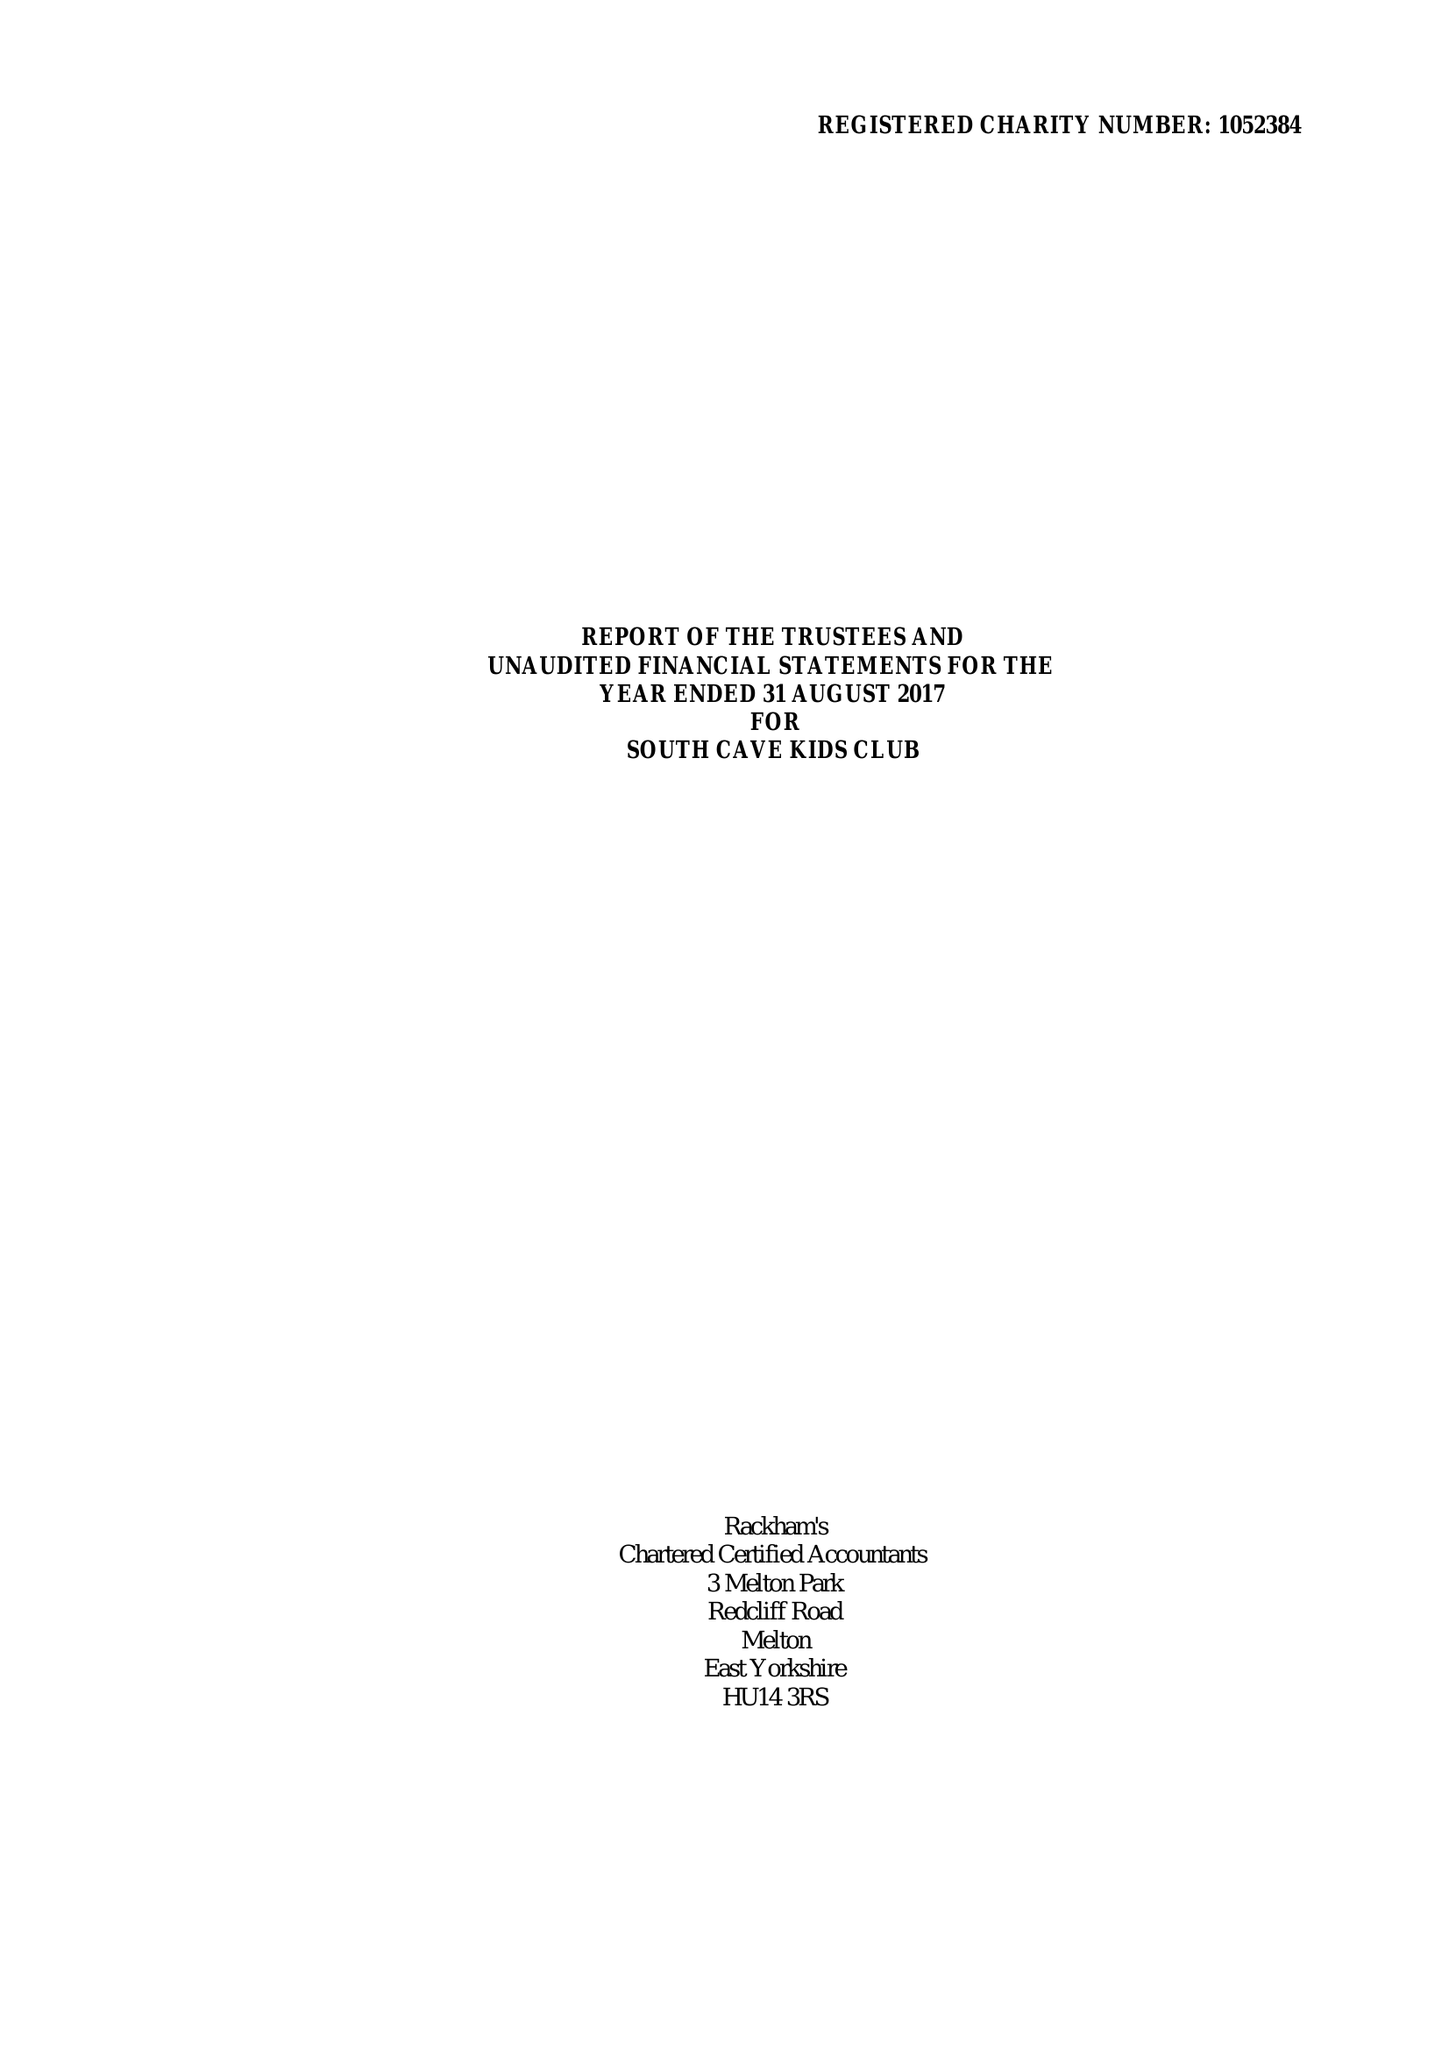What is the value for the address__street_line?
Answer the question using a single word or phrase. CHURCH STREET 